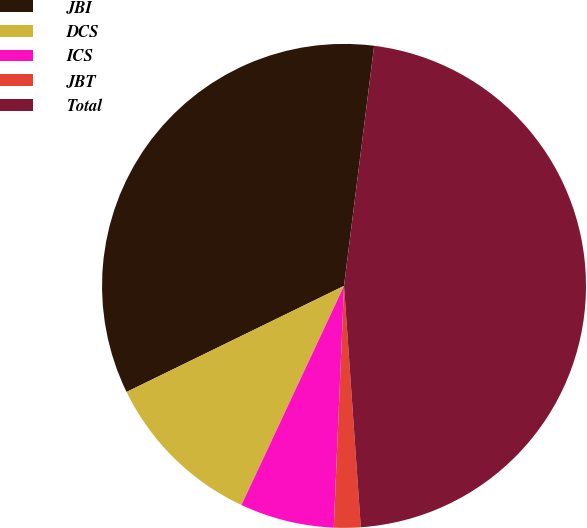Convert chart. <chart><loc_0><loc_0><loc_500><loc_500><pie_chart><fcel>JBI<fcel>DCS<fcel>ICS<fcel>JBT<fcel>Total<nl><fcel>34.21%<fcel>10.81%<fcel>6.29%<fcel>1.78%<fcel>46.91%<nl></chart> 